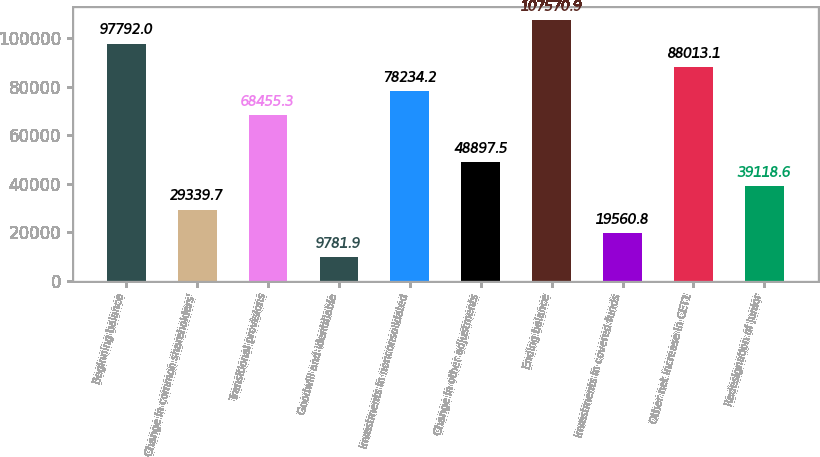Convert chart to OTSL. <chart><loc_0><loc_0><loc_500><loc_500><bar_chart><fcel>Beginning balance<fcel>Change in common shareholders'<fcel>Transitional provisions<fcel>Goodwill and identifiable<fcel>Investments in nonconsolidated<fcel>Change in other adjustments<fcel>Ending balance<fcel>Investments in covered funds<fcel>Other net increase in CET1<fcel>Redesignation of junior<nl><fcel>97792<fcel>29339.7<fcel>68455.3<fcel>9781.9<fcel>78234.2<fcel>48897.5<fcel>107571<fcel>19560.8<fcel>88013.1<fcel>39118.6<nl></chart> 